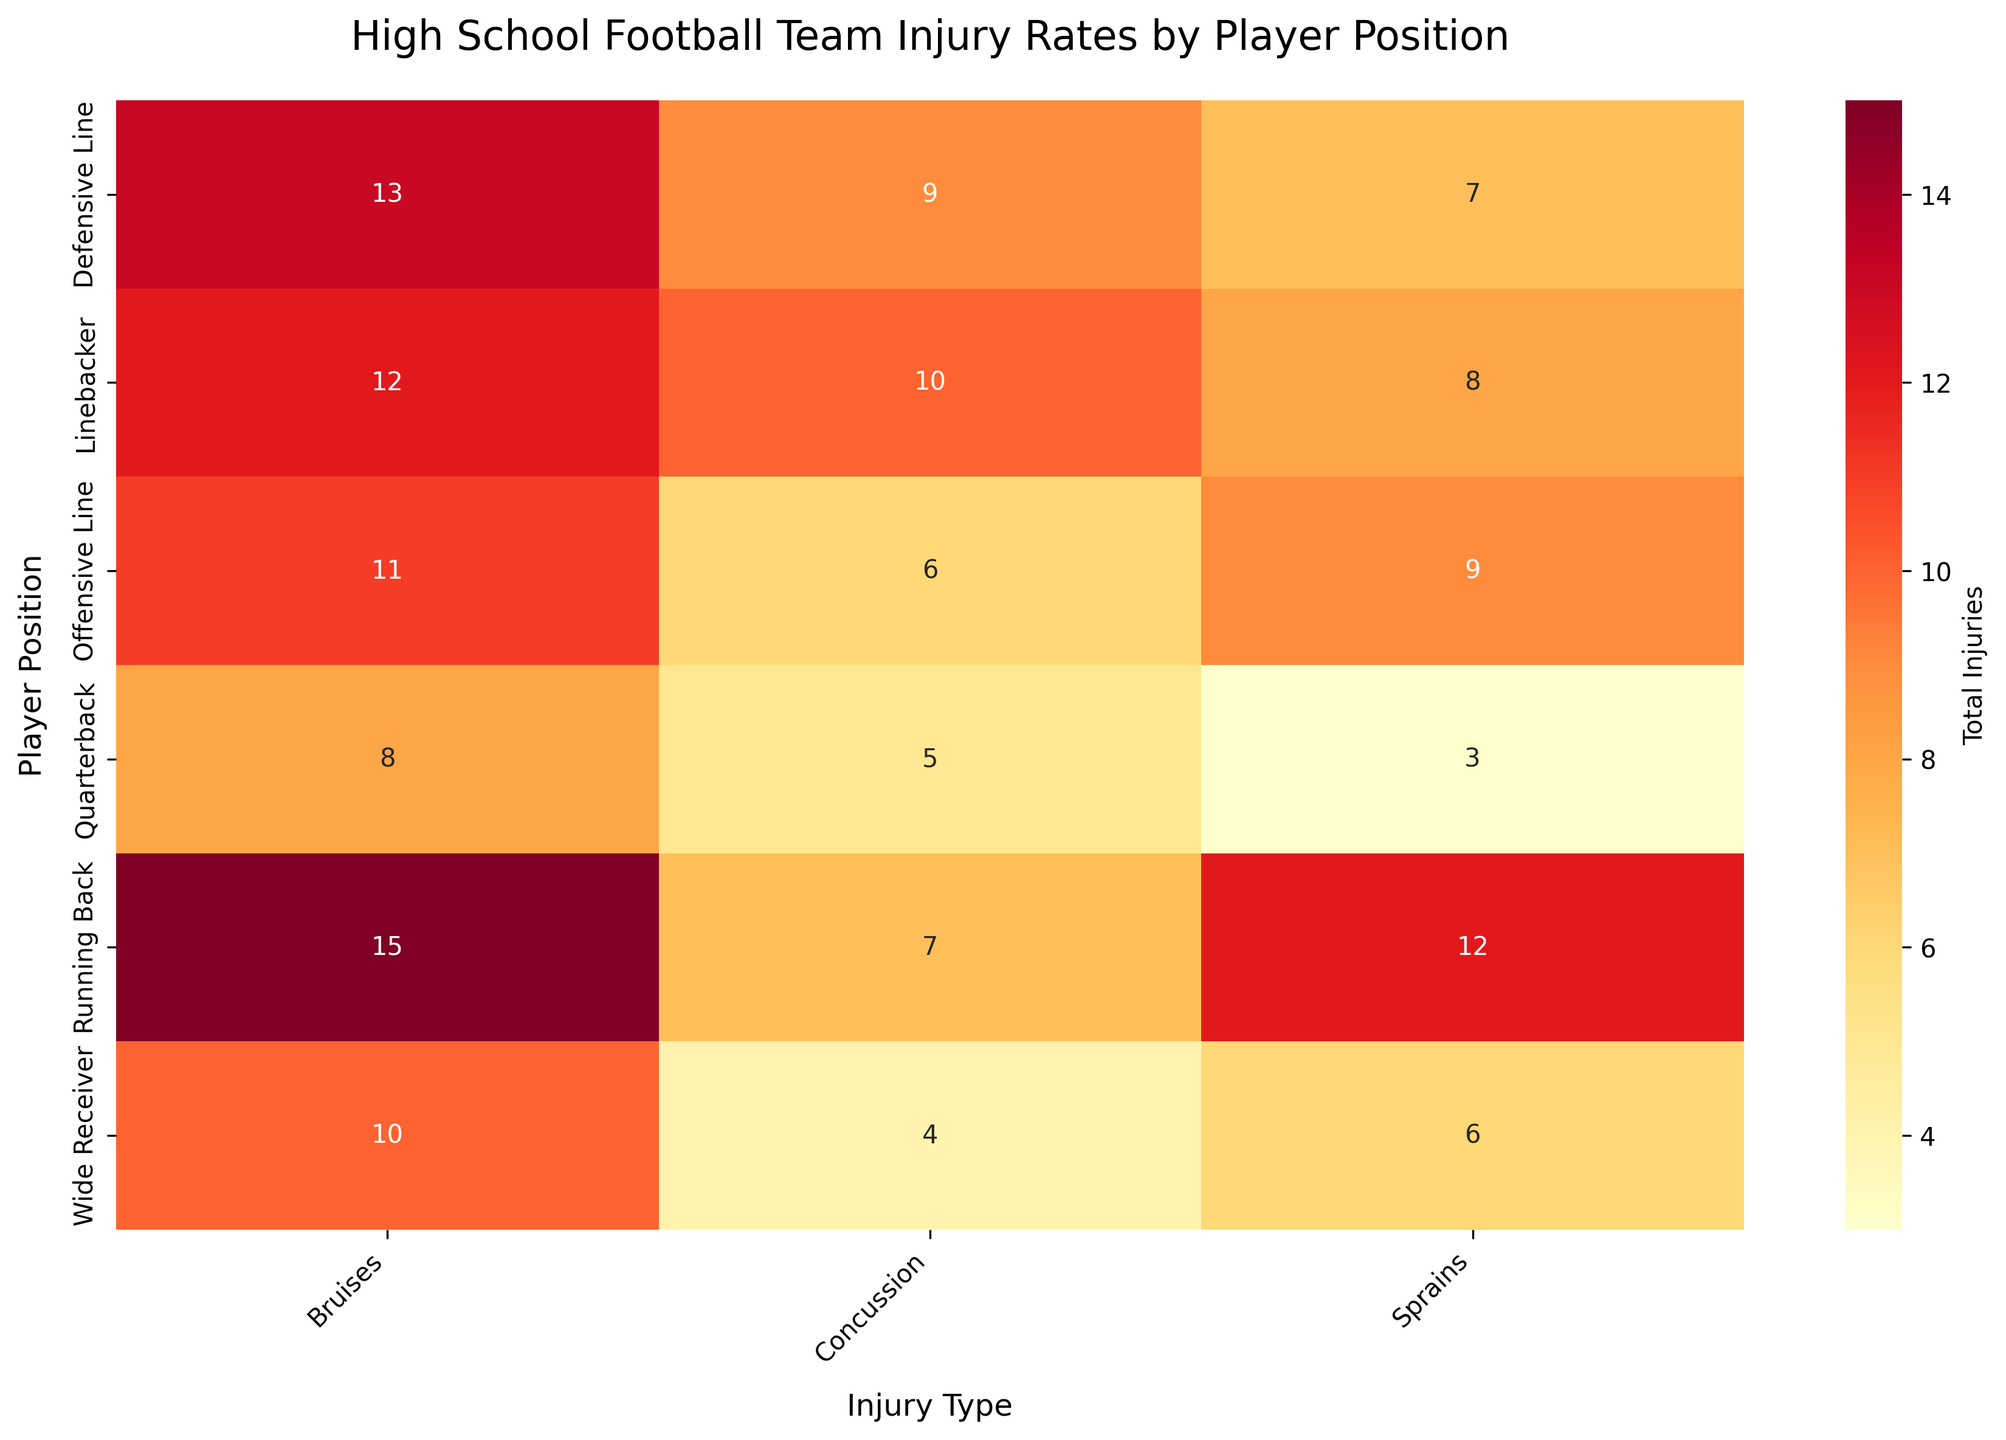What is the title of the heatmap? The title is usually displayed at the top of the heatmap in a larger font size. It gives an overview of what the data representation is about.
Answer: High School Football Team Injury Rates by Player Position What is the total number of injuries for quarterbacks? Sum the number of injuries (Concussion, Sprains, Bruises) for quarterbacks: 5 (Concussion) + 3 (Sprains) + 8 (Bruises) = 16.
Answer: 16 Which player position has the highest number of concussions? Among the given player positions, compare the numbers in the "Concussion" column to find the highest value.
Answer: Linebacker How many more bruises do running backs have compared to wide receivers? Subtract the number of bruises for wide receivers from the number of bruises for running backs: 15 (Running Back) - 10 (Wide Receiver) = 5.
Answer: 5 What is the average number of sprains for linebackers and offensive linemen? Find the average by summing the number of sprains for linebackers and offensive linemen and dividing by 2: (8 (Linebacker) + 9 (Offensive Line)) / 2 = 17 / 2 = 8.5.
Answer: 8.5 Which injury type has the least number of total injuries for running backs? Compare the numbers of concussions, sprains, and bruises for running backs.
Answer: Concussion Do linebackers have more total injuries than defensive linemen? Calculate the total injuries for both positions and compare: 
Linebacker: 10 (Concussion) + 8 (Sprains) + 12 (Bruises) = 30
Defensive Line: 9 (Concussion) + 7 (Sprains) + 13 (Bruises) = 29
Compare the two totals.
Answer: Yes Which player position has the fewest injuries overall? Sum the injuries for each position and find the position with the smallest total:
Quarterback = 16
Running Back = 34
Wide Receiver = 20
Linebacker = 30
Offensive Line = 26
Defensive Line = 29
Answer: Quarterback Which player position has the highest number of injuries from sprains? Compare the numbers in the "Sprains" column to find the highest value among the player positions.
Answer: Running Back How do the total injuries for wide receivers compare to those for offensive linemen? Calculate the total injuries for both positions and compare:
Wide Receiver: 4 (Concussion) + 6 (Sprains) + 10 (Bruises) = 20
Offensive Line: 6 (Concussion) + 9 (Sprains) + 11 (Bruises) = 26
Compare the two totals to determine which is higher.
Answer: Offensive Line has more injuries 